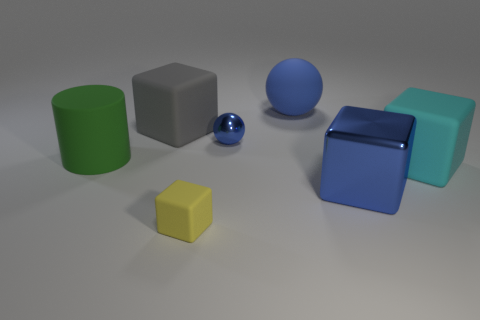Subtract all big gray matte blocks. How many blocks are left? 3 Add 2 large green cylinders. How many objects exist? 9 Subtract all yellow blocks. How many blocks are left? 3 Subtract 2 blocks. How many blocks are left? 2 Add 6 tiny yellow rubber objects. How many tiny yellow rubber objects are left? 7 Add 6 big green shiny balls. How many big green shiny balls exist? 6 Subtract 0 brown blocks. How many objects are left? 7 Subtract all cylinders. How many objects are left? 6 Subtract all cyan cylinders. Subtract all green balls. How many cylinders are left? 1 Subtract all blue cylinders. How many gray cubes are left? 1 